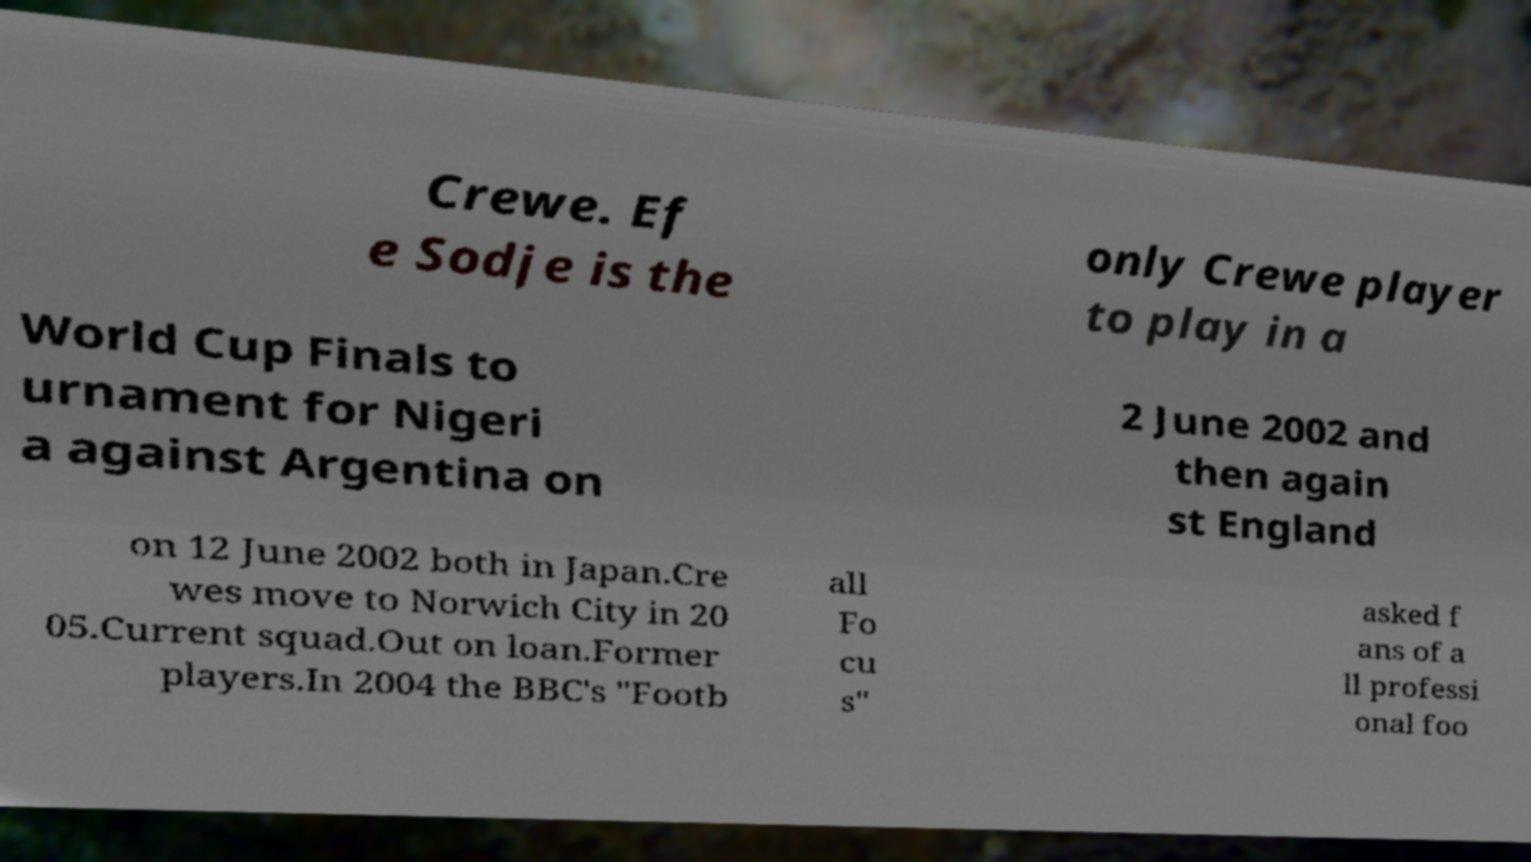What messages or text are displayed in this image? I need them in a readable, typed format. Crewe. Ef e Sodje is the only Crewe player to play in a World Cup Finals to urnament for Nigeri a against Argentina on 2 June 2002 and then again st England on 12 June 2002 both in Japan.Cre wes move to Norwich City in 20 05.Current squad.Out on loan.Former players.In 2004 the BBC's "Footb all Fo cu s" asked f ans of a ll professi onal foo 